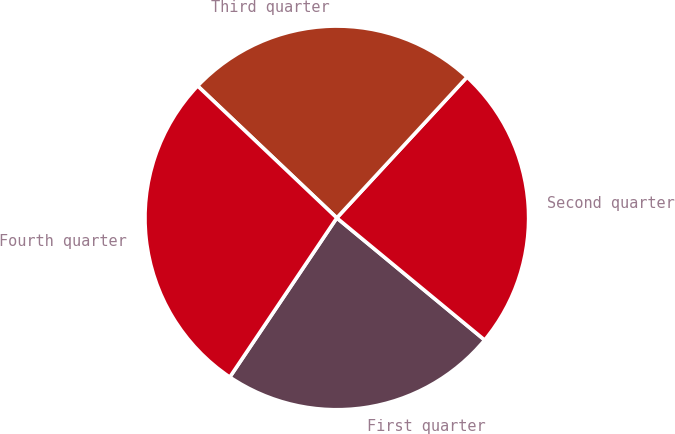Convert chart. <chart><loc_0><loc_0><loc_500><loc_500><pie_chart><fcel>First quarter<fcel>Second quarter<fcel>Third quarter<fcel>Fourth quarter<nl><fcel>23.43%<fcel>24.11%<fcel>24.8%<fcel>27.66%<nl></chart> 